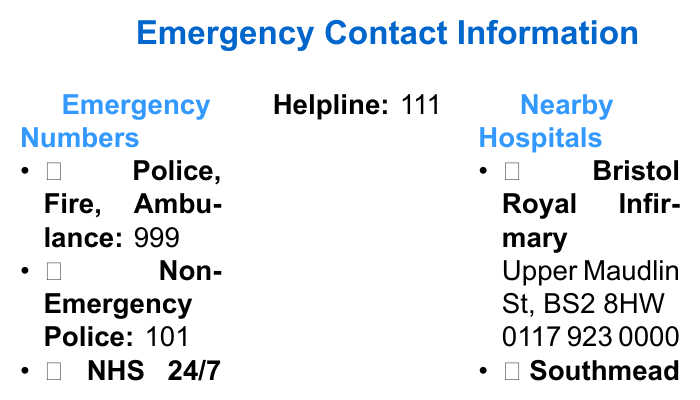What is the phone number for the NHS Helpline? The document lists the phone number for the NHS 24/7 Helpline as 111.
Answer: 111 What is the address of Southmead Hospital? The document provides Southmead Hospital's address as Southmead Rd, BS10 5NB.
Answer: Southmead Rd, BS10 5NB What emergency number should you call for the police, fire, or ambulance? The document states that the number to call for police, fire, or ambulance is 999.
Answer: 999 What contact number is provided for Bristol City Council? The document indicates that the contact number for Bristol City Council is 0117 922 2000.
Answer: 0117 922 2000 How many nearby hospitals are listed in the document? The document mentions two nearby hospitals: Bristol Royal Infirmary and Southmead Hospital.
Answer: Two Which hospital's phone number is 0117 923 0000? According to the document, the phone number 0117 923 0000 belongs to Bristol Royal Infirmary.
Answer: Bristol Royal Infirmary What is the color theme used for the title in the document? The title color is specified as RGB color 0,102,204 in the document.
Answer: RGB 0,102,204 What kind of emergencies can you report at 0800 111 999? The document specifies that this number is for gas emergencies.
Answer: Gas Emergency 